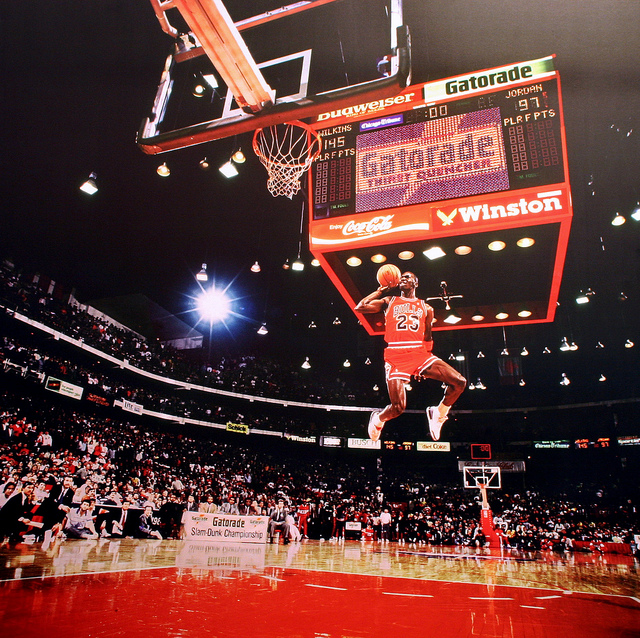Identify the text displayed in this image. Gatorade JOROAN Budweiser HILKINS 00 145 Gatorade THIRST QUINCER Winston Championship Gatorade PLRFPTS PLRFPTS 97 23 Coca Cola 